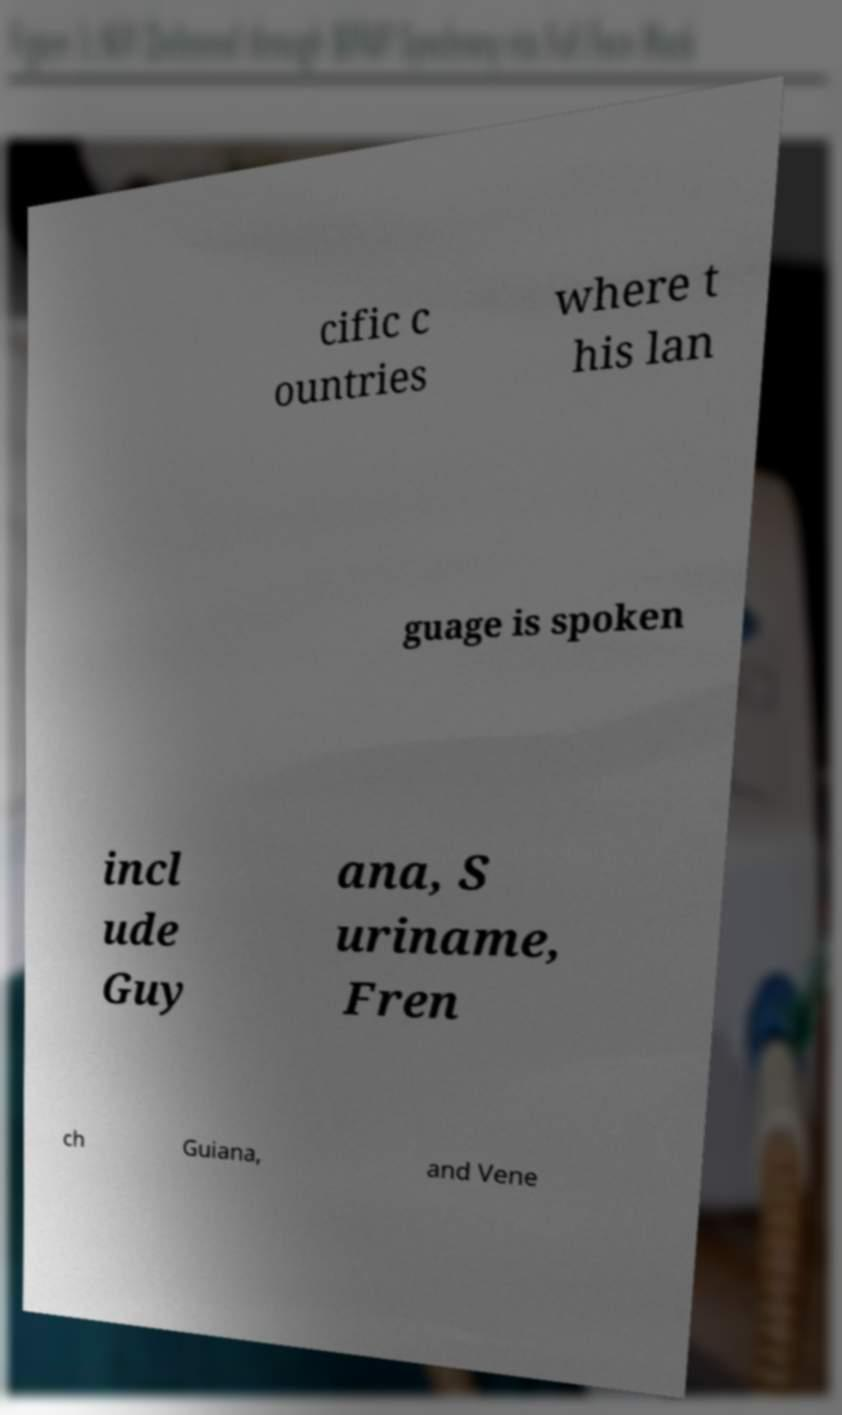There's text embedded in this image that I need extracted. Can you transcribe it verbatim? cific c ountries where t his lan guage is spoken incl ude Guy ana, S uriname, Fren ch Guiana, and Vene 